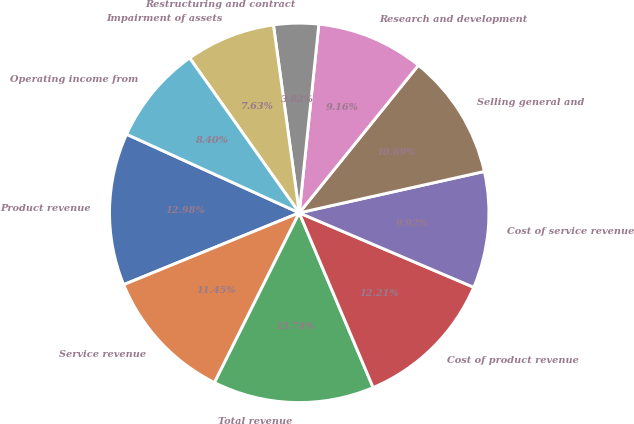Convert chart to OTSL. <chart><loc_0><loc_0><loc_500><loc_500><pie_chart><fcel>Product revenue<fcel>Service revenue<fcel>Total revenue<fcel>Cost of product revenue<fcel>Cost of service revenue<fcel>Selling general and<fcel>Research and development<fcel>Restructuring and contract<fcel>Impairment of assets<fcel>Operating income from<nl><fcel>12.98%<fcel>11.45%<fcel>13.74%<fcel>12.21%<fcel>9.92%<fcel>10.69%<fcel>9.16%<fcel>3.82%<fcel>7.63%<fcel>8.4%<nl></chart> 